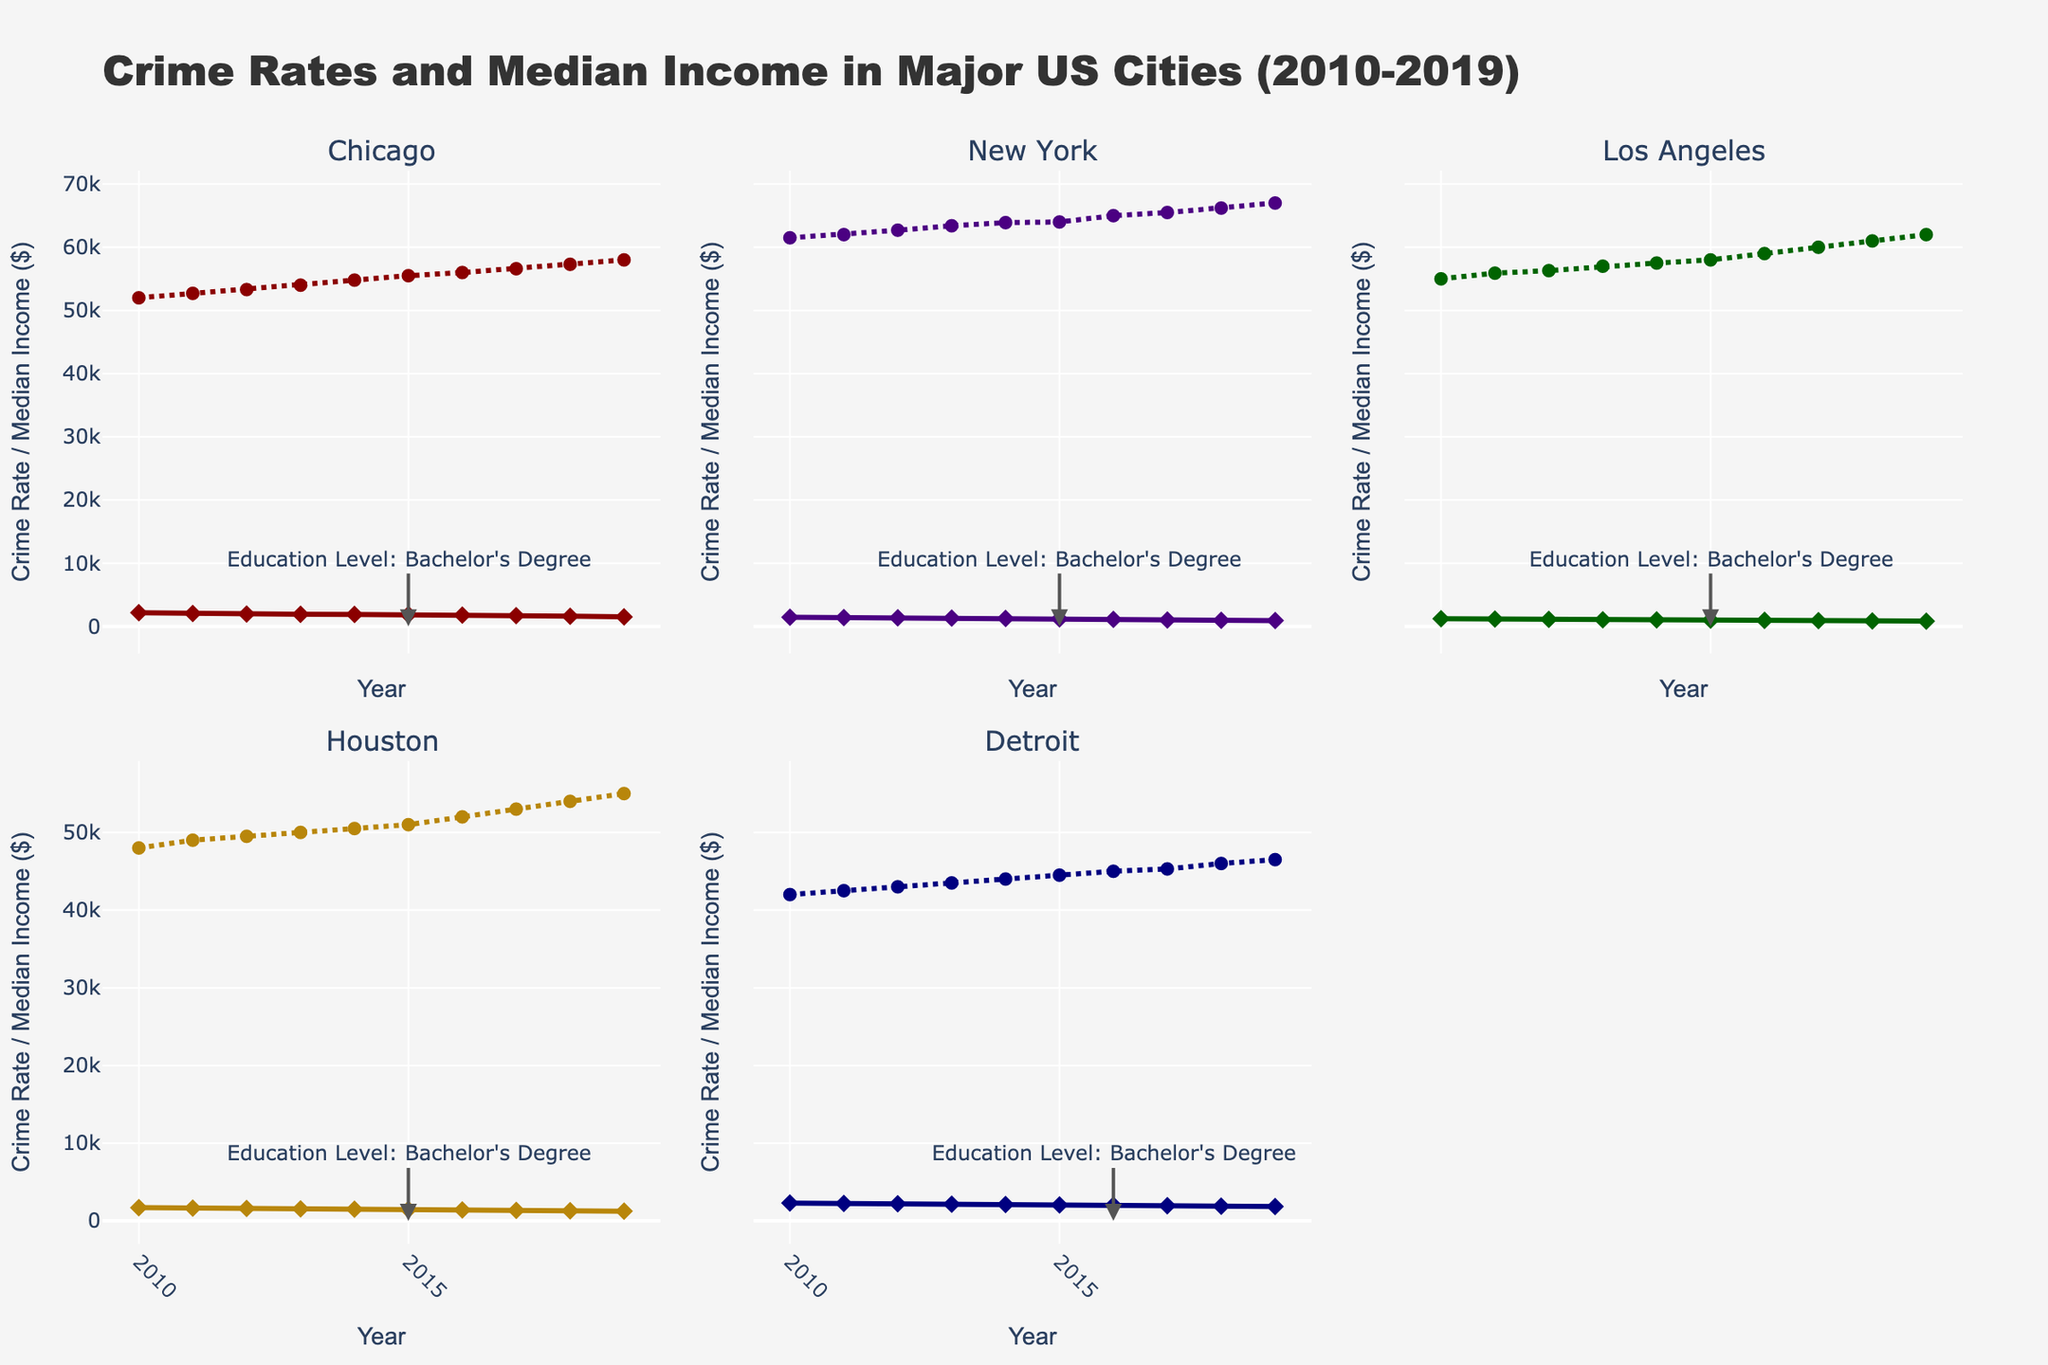What is the trend of the crime rate in Chicago from 2010 to 2019? Observing the plot of Chicago, the line representing the crime rate shows a downward trend from 2010 to 2019, indicating a decrease in crime rate over the years.
Answer: Downward trend How does the median income in New York change from 2010 to 2019? The line representing the median income in New York shows an upward trend from 2010 to 2019, indicating a steady increase in income over the years.
Answer: Upward trend In which year did Detroit experience a change in education level to a bachelor's degree? By locating the annotation on Detroit's subplot, the year when the education level changed to a bachelor's degree is displayed.
Answer: 2016 Which city had the highest crime rate in 2010? By comparing the starting points of the crime rate lines for 2010 on each subplot, Detroit has the highest value.
Answer: Detroit What is the average median income in Los Angeles in 2015 and 2016? The median income in Los Angeles in 2015 is $58000 and in 2016 is $59000. Sum these values and divide by 2: (58000 + 59000) / 2 = 58500.
Answer: 58500 Is the crime rate in Detroit higher than in Houston in 2019? By comparing the end points of the crime rate lines for 2019 in Detroit and Houston, Detroit's value is higher.
Answer: Yes What is the difference in the crime rate of Chicago between 2010 and 2019? The crime rate in Chicago in 2010 is 2164 and in 2019 is 1500. The difference is 2164 - 1500 = 664.
Answer: 664 Which city saw the greatest reduction in crime rate from 2010 to 2019? By comparing the difference between 2010 and 2019 crime rates for all cities, New York shows the greatest reduction.
Answer: New York How does the crime rate trend in Los Angeles compare with that in Houston from 2010 to 2019? By looking at the plots for Los Angeles and Houston, both crime rates show a downward trend from 2010 to 2019.
Answer: Both downward What is the median income in Chicago when the education level reached a bachelor's degree? The education level in Chicago changed to a bachelor's degree starting in 2015. The median income at that time is $55500.
Answer: 55500 